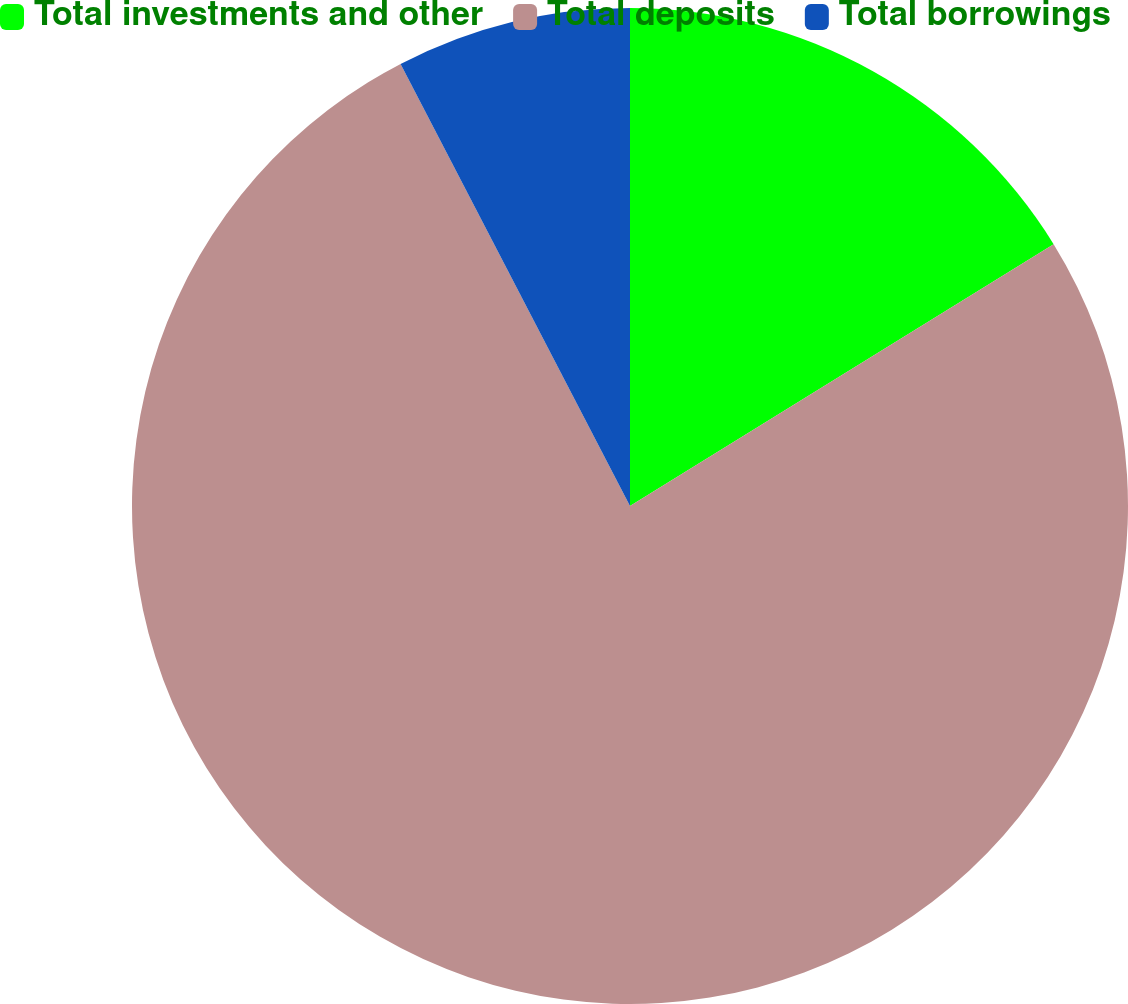Convert chart. <chart><loc_0><loc_0><loc_500><loc_500><pie_chart><fcel>Total investments and other<fcel>Total deposits<fcel>Total borrowings<nl><fcel>16.19%<fcel>76.19%<fcel>7.62%<nl></chart> 